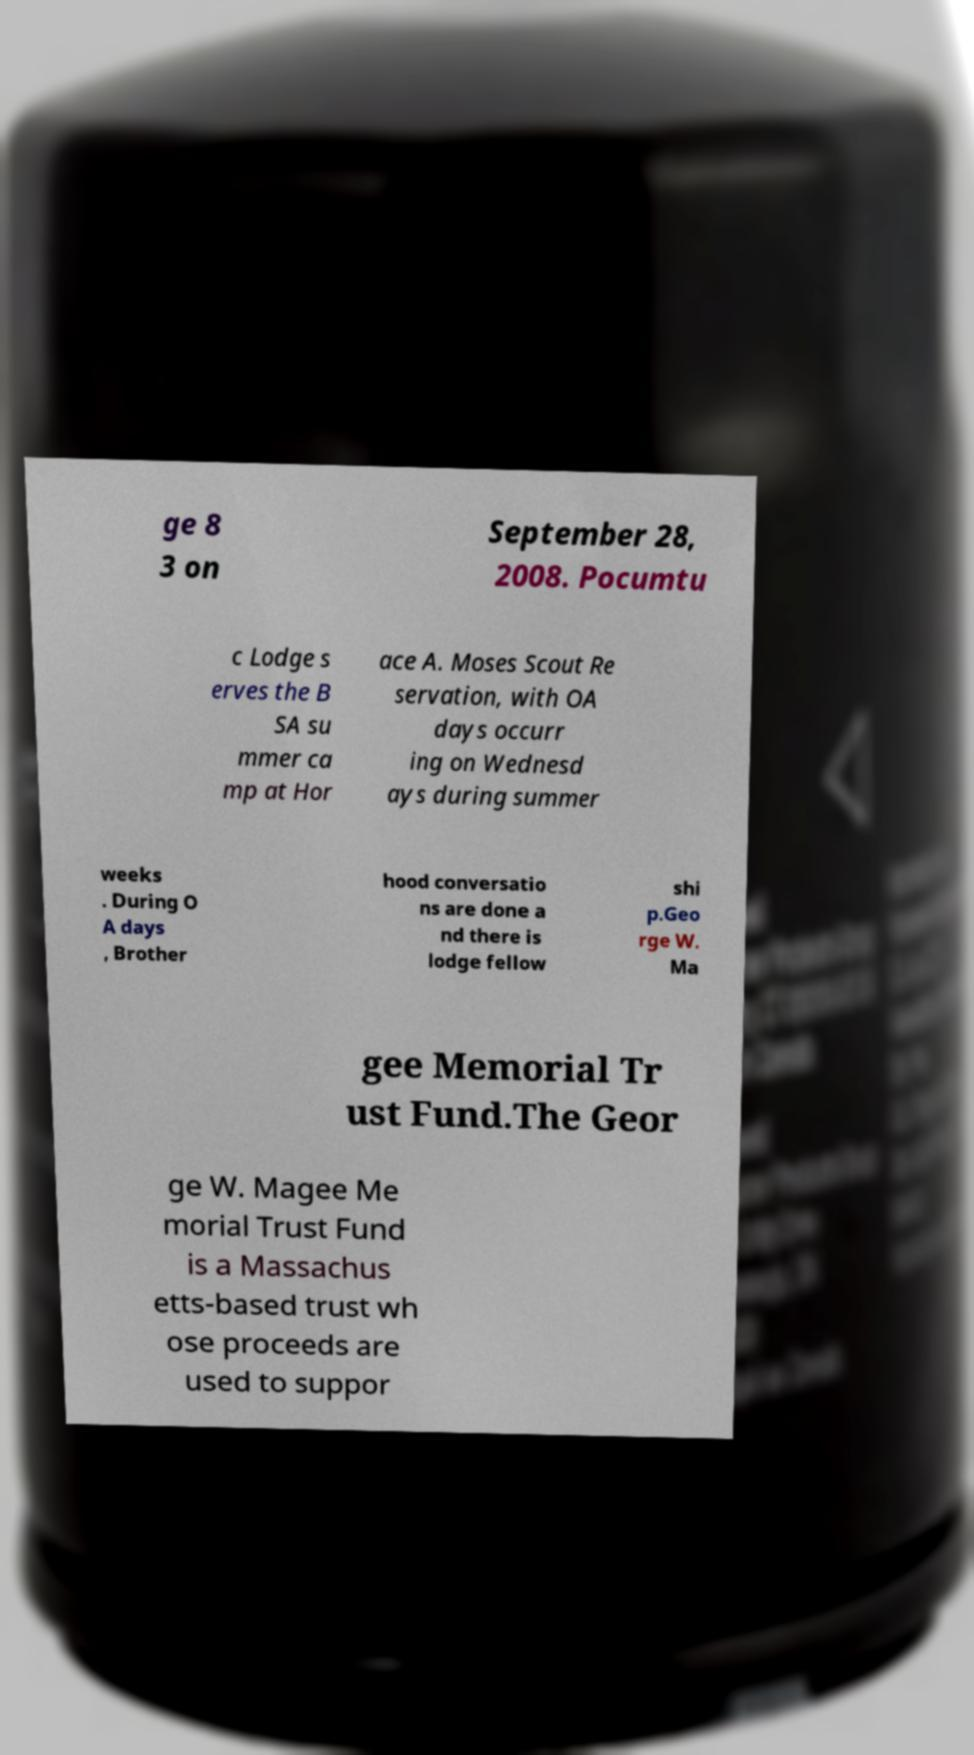Please read and relay the text visible in this image. What does it say? ge 8 3 on September 28, 2008. Pocumtu c Lodge s erves the B SA su mmer ca mp at Hor ace A. Moses Scout Re servation, with OA days occurr ing on Wednesd ays during summer weeks . During O A days , Brother hood conversatio ns are done a nd there is lodge fellow shi p.Geo rge W. Ma gee Memorial Tr ust Fund.The Geor ge W. Magee Me morial Trust Fund is a Massachus etts-based trust wh ose proceeds are used to suppor 